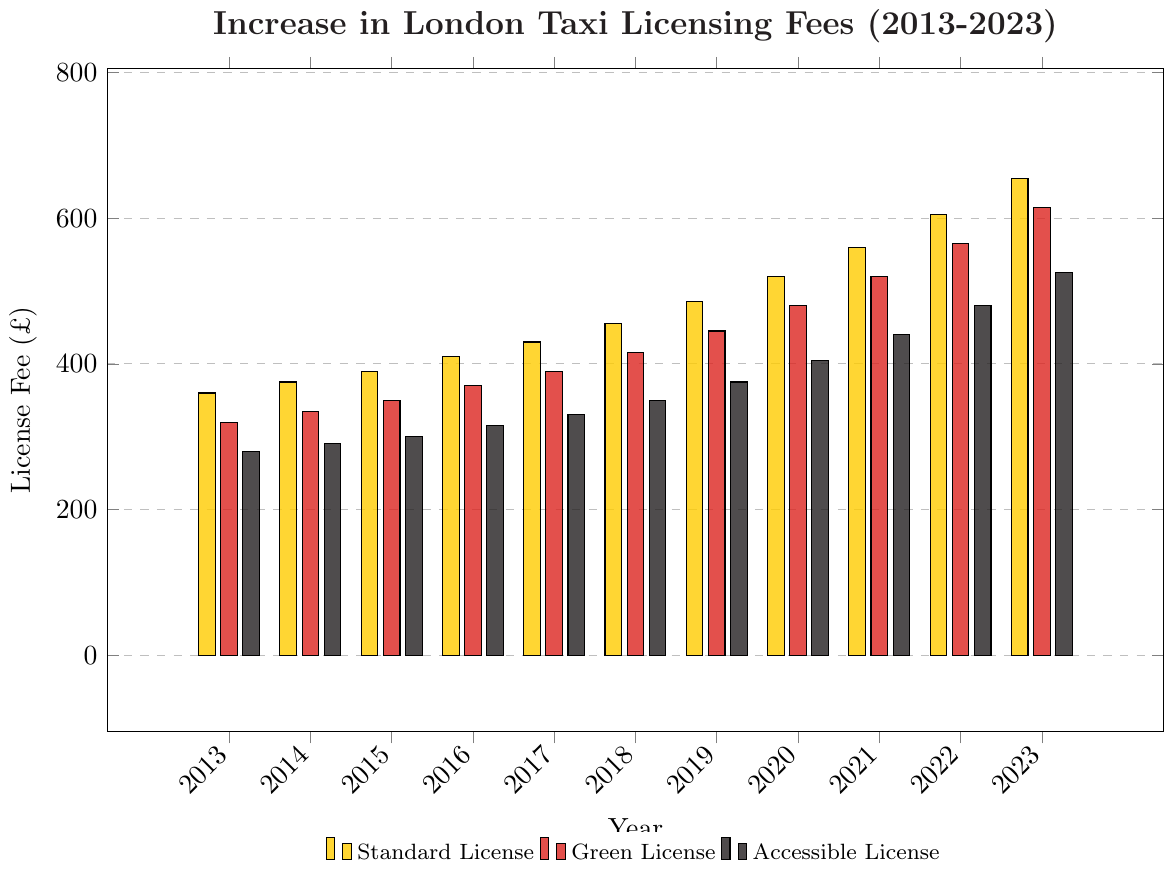Which license type had the highest fee in 2023? By looking at the heights of the bars for the year 2023, we can compare the values. The tallest bar corresponds to the Standard License.
Answer: Standard License How much did the fee for the Green License increase from 2019 to 2023? For the Green License, the fee in 2019 is £445 and in 2023 is £615. So, the increase is 615 - 445.
Answer: £170 Which license type had the smallest increase in fees from 2013 to 2023? Calculate the increase for each license type: Standard (655-360), Green (615-320), Accessible (525-280). Compare the differences: 295, 295, and 245 respectively. The smallest increase is for the Accessible License.
Answer: Accessible License What is the average fee for the Standard License over the decade? Sum the Standard License fees from 2013 to 2023 and divide by the number of years: (360 + 375 + 390 + 410 + 430 + 455 + 485 + 520 + 560 + 605 + 655) / 11. Total = 5245, so average is 5245 / 11.
Answer: £477.73 By how much did the fees for the Accessible License increase each year on average? Calculate the total increase over the decade for Accessible License, then divide by the number of increases (10): (525-280) / 10. Total increase is 245, so average is 245 / 10.
Answer: £24.50 per year What year did the Green License fee first exceed £500? Identify the first year in the Green License bar series where the fee is greater than £500. This happens in 2021.
Answer: 2021 Between which consecutive years did the Standard License fee increase the most? Calculate the year-to-year differences for Standard License: 15, 15, 20, 20, 25, 30, 35, 40, 45, 50. The largest increase is from 2022 to 2023 with a difference of 50.
Answer: 2022-2023 How does the fee for the Accessible License in 2016 compare to the fee for the Green License in the same year? By comparing the heights of the bars for the year 2016: Accessible License fee is £315 and Green License fee is £370.
Answer: Accessible License is £55 less What color represents the fee for the Green License? Identify the color of the bar corresponding to the Green License in the legend.
Answer: Red 